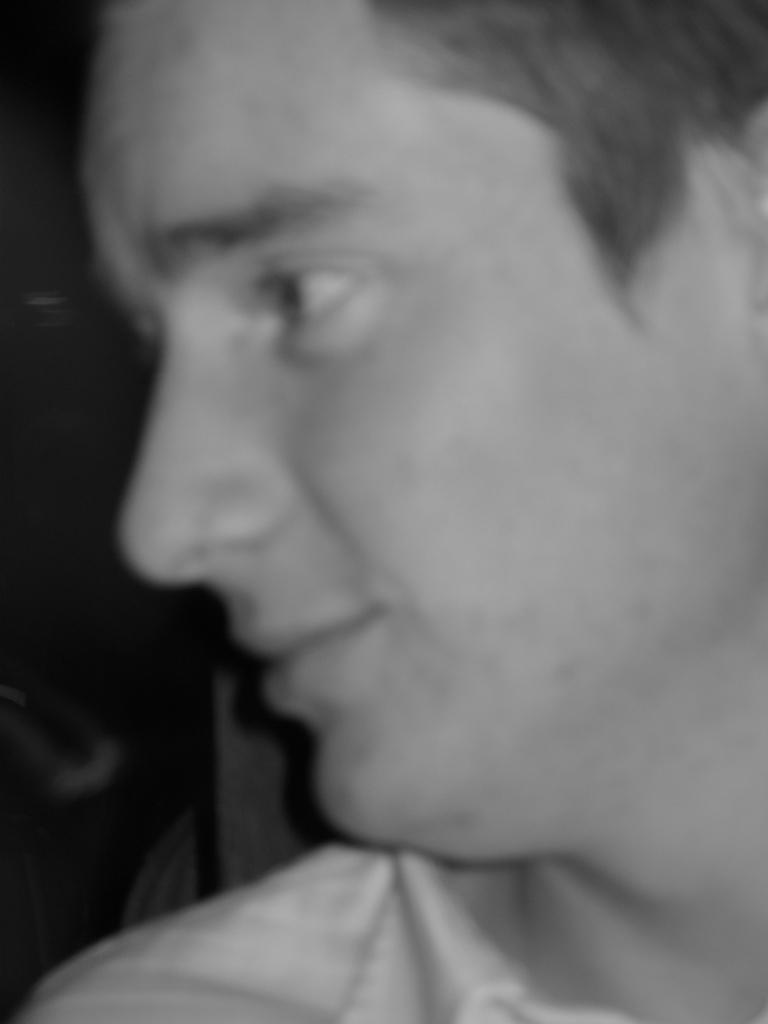Could you give a brief overview of what you see in this image? This is a black and white picture. In this picture we can see the face of a person. 